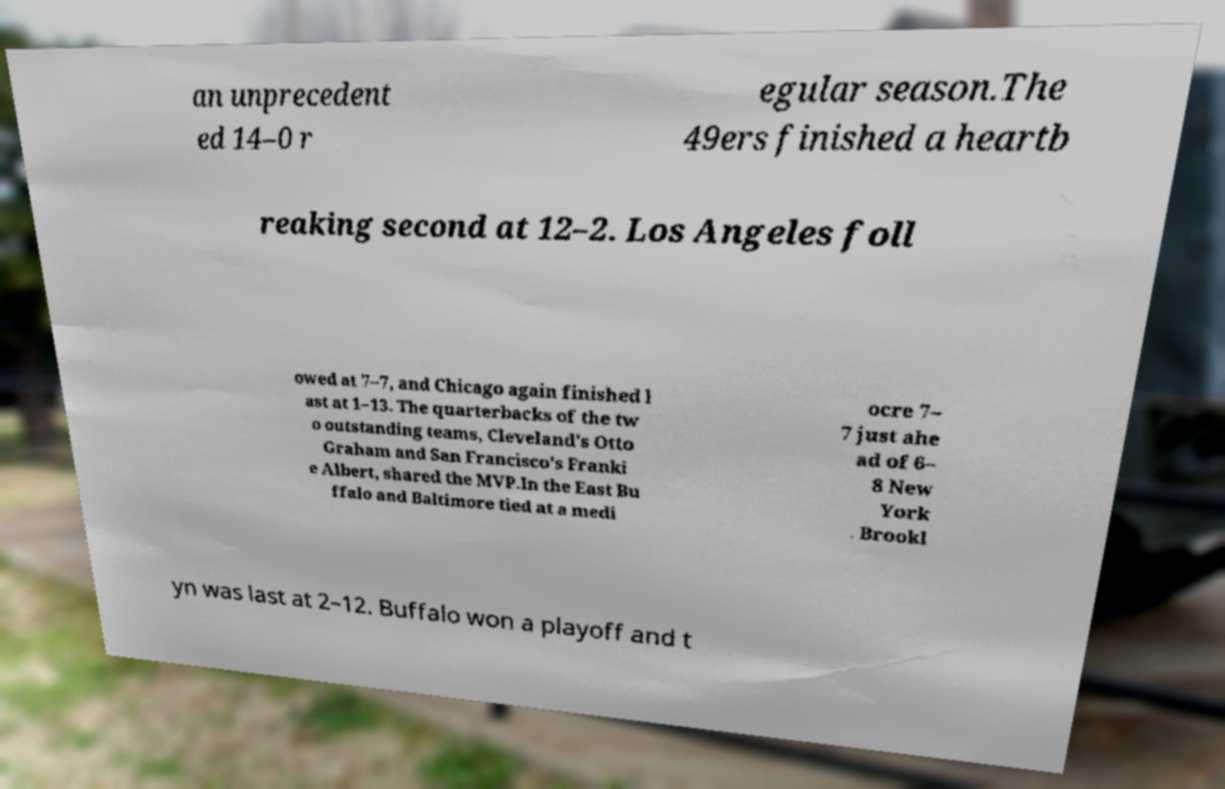Could you extract and type out the text from this image? an unprecedent ed 14–0 r egular season.The 49ers finished a heartb reaking second at 12–2. Los Angeles foll owed at 7–7, and Chicago again finished l ast at 1–13. The quarterbacks of the tw o outstanding teams, Cleveland's Otto Graham and San Francisco's Franki e Albert, shared the MVP.In the East Bu ffalo and Baltimore tied at a medi ocre 7– 7 just ahe ad of 6– 8 New York . Brookl yn was last at 2–12. Buffalo won a playoff and t 